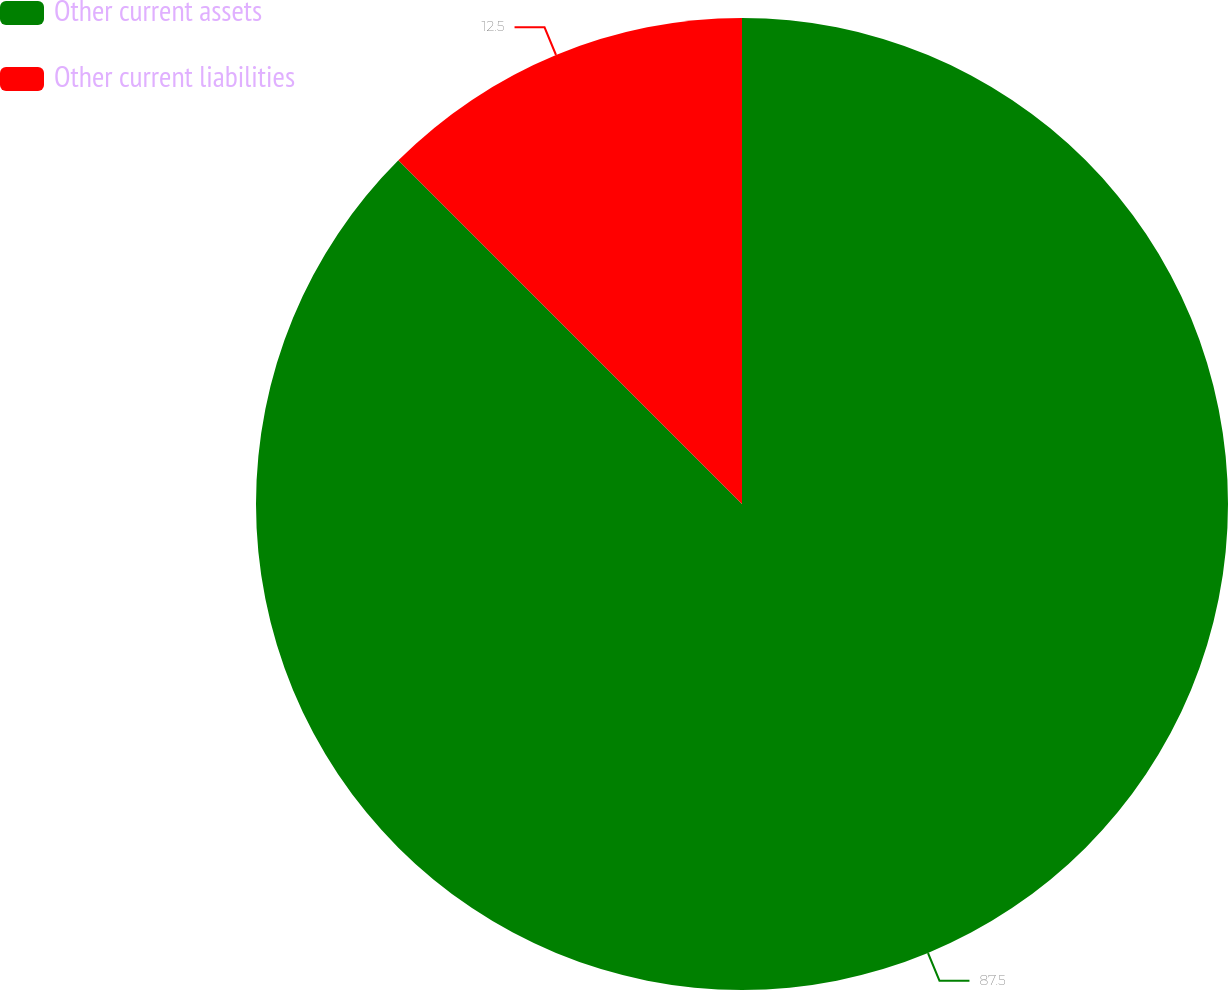Convert chart. <chart><loc_0><loc_0><loc_500><loc_500><pie_chart><fcel>Other current assets<fcel>Other current liabilities<nl><fcel>87.5%<fcel>12.5%<nl></chart> 